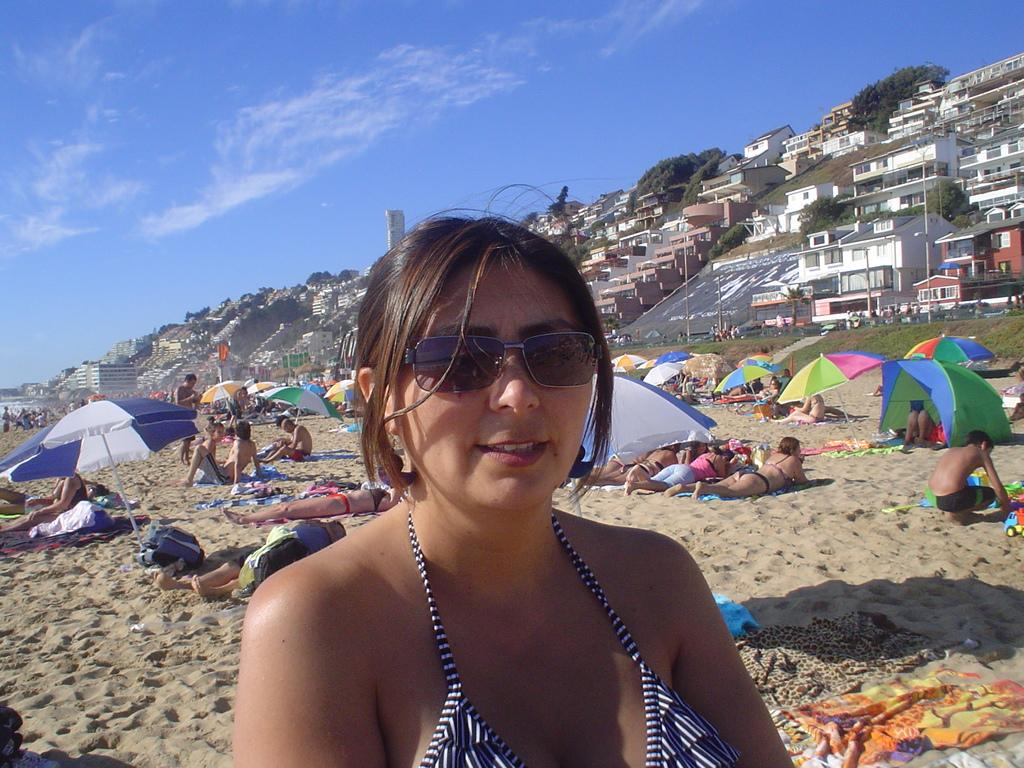Who or what is present in the image? There are people in the image. What objects are being used by the people in the image? There are umbrellas in the image. What type of terrain is visible in the image? There is sand in the image. What type of vegetation is present in the image? There are plants in the image. What type of structures can be seen in the image? There are houses in the image. What is visible in the background of the image? The sky is visible in the background of the image. What type of ornament is hanging from the umbrella in the image? There is no ornament hanging from the umbrella in the image. Can you touch the plants in the image? You cannot touch the plants in the image, as it is a two-dimensional representation. 